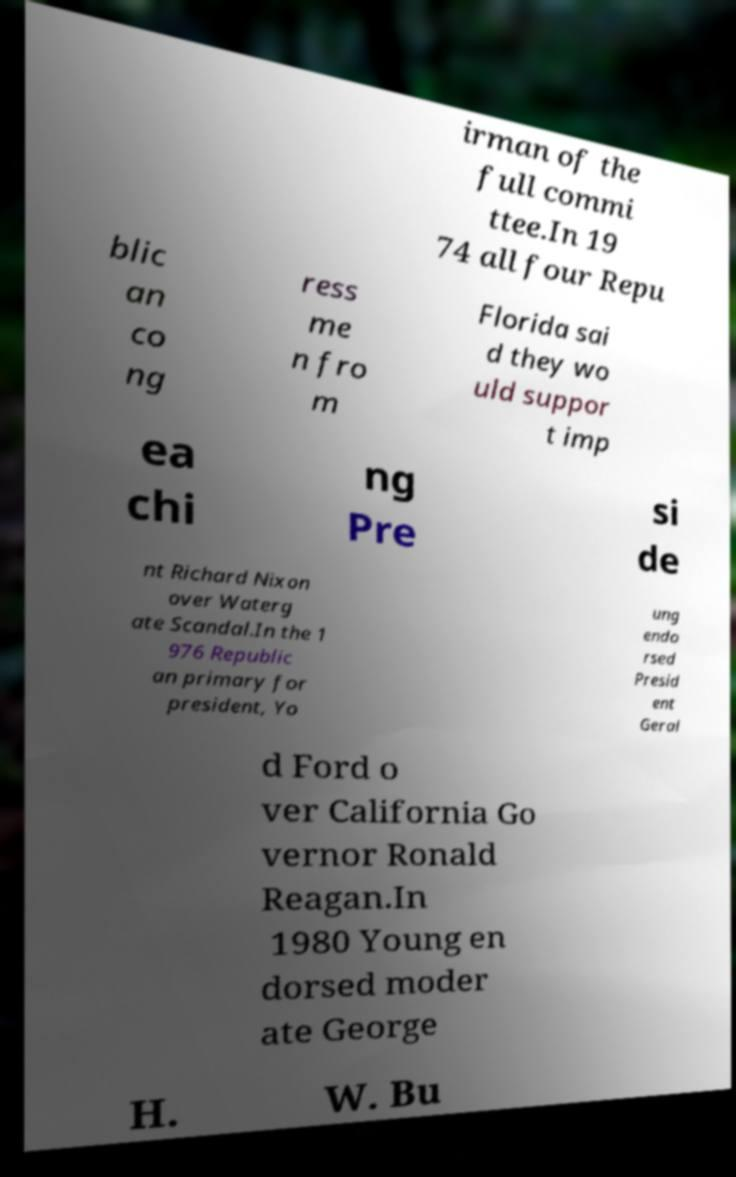Can you accurately transcribe the text from the provided image for me? irman of the full commi ttee.In 19 74 all four Repu blic an co ng ress me n fro m Florida sai d they wo uld suppor t imp ea chi ng Pre si de nt Richard Nixon over Waterg ate Scandal.In the 1 976 Republic an primary for president, Yo ung endo rsed Presid ent Geral d Ford o ver California Go vernor Ronald Reagan.In 1980 Young en dorsed moder ate George H. W. Bu 